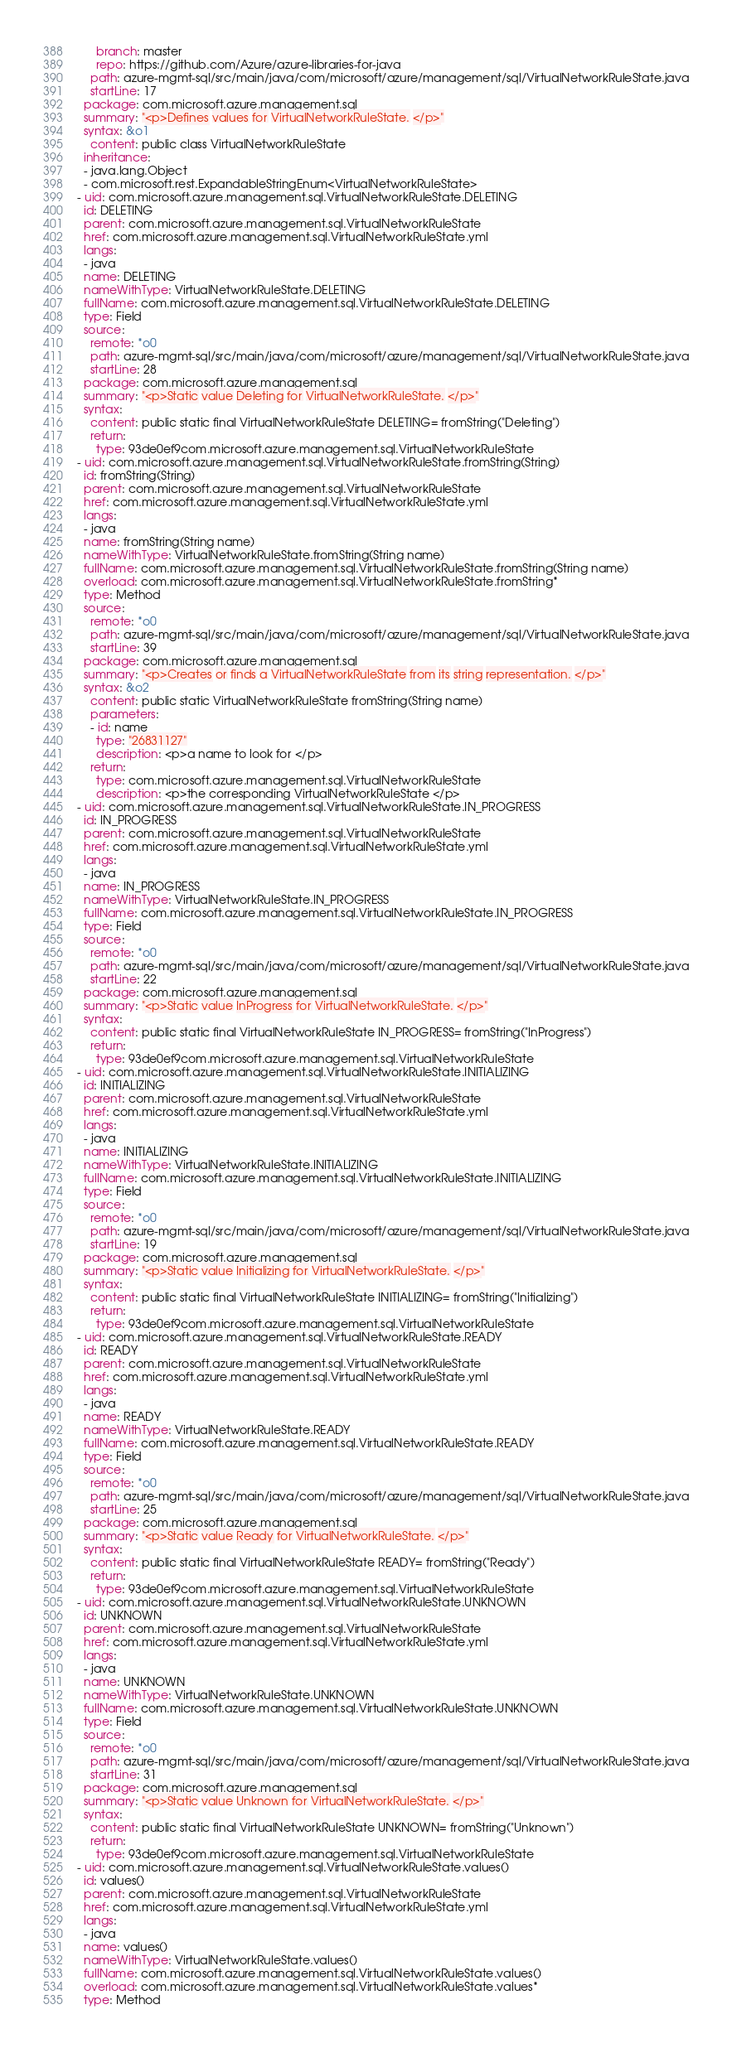Convert code to text. <code><loc_0><loc_0><loc_500><loc_500><_YAML_>      branch: master
      repo: https://github.com/Azure/azure-libraries-for-java
    path: azure-mgmt-sql/src/main/java/com/microsoft/azure/management/sql/VirtualNetworkRuleState.java
    startLine: 17
  package: com.microsoft.azure.management.sql
  summary: "<p>Defines values for VirtualNetworkRuleState. </p>"
  syntax: &o1
    content: public class VirtualNetworkRuleState
  inheritance:
  - java.lang.Object
  - com.microsoft.rest.ExpandableStringEnum<VirtualNetworkRuleState>
- uid: com.microsoft.azure.management.sql.VirtualNetworkRuleState.DELETING
  id: DELETING
  parent: com.microsoft.azure.management.sql.VirtualNetworkRuleState
  href: com.microsoft.azure.management.sql.VirtualNetworkRuleState.yml
  langs:
  - java
  name: DELETING
  nameWithType: VirtualNetworkRuleState.DELETING
  fullName: com.microsoft.azure.management.sql.VirtualNetworkRuleState.DELETING
  type: Field
  source:
    remote: *o0
    path: azure-mgmt-sql/src/main/java/com/microsoft/azure/management/sql/VirtualNetworkRuleState.java
    startLine: 28
  package: com.microsoft.azure.management.sql
  summary: "<p>Static value Deleting for VirtualNetworkRuleState. </p>"
  syntax:
    content: public static final VirtualNetworkRuleState DELETING= fromString("Deleting")
    return:
      type: 93de0ef9com.microsoft.azure.management.sql.VirtualNetworkRuleState
- uid: com.microsoft.azure.management.sql.VirtualNetworkRuleState.fromString(String)
  id: fromString(String)
  parent: com.microsoft.azure.management.sql.VirtualNetworkRuleState
  href: com.microsoft.azure.management.sql.VirtualNetworkRuleState.yml
  langs:
  - java
  name: fromString(String name)
  nameWithType: VirtualNetworkRuleState.fromString(String name)
  fullName: com.microsoft.azure.management.sql.VirtualNetworkRuleState.fromString(String name)
  overload: com.microsoft.azure.management.sql.VirtualNetworkRuleState.fromString*
  type: Method
  source:
    remote: *o0
    path: azure-mgmt-sql/src/main/java/com/microsoft/azure/management/sql/VirtualNetworkRuleState.java
    startLine: 39
  package: com.microsoft.azure.management.sql
  summary: "<p>Creates or finds a VirtualNetworkRuleState from its string representation. </p>"
  syntax: &o2
    content: public static VirtualNetworkRuleState fromString(String name)
    parameters:
    - id: name
      type: "26831127"
      description: <p>a name to look for </p>
    return:
      type: com.microsoft.azure.management.sql.VirtualNetworkRuleState
      description: <p>the corresponding VirtualNetworkRuleState </p>
- uid: com.microsoft.azure.management.sql.VirtualNetworkRuleState.IN_PROGRESS
  id: IN_PROGRESS
  parent: com.microsoft.azure.management.sql.VirtualNetworkRuleState
  href: com.microsoft.azure.management.sql.VirtualNetworkRuleState.yml
  langs:
  - java
  name: IN_PROGRESS
  nameWithType: VirtualNetworkRuleState.IN_PROGRESS
  fullName: com.microsoft.azure.management.sql.VirtualNetworkRuleState.IN_PROGRESS
  type: Field
  source:
    remote: *o0
    path: azure-mgmt-sql/src/main/java/com/microsoft/azure/management/sql/VirtualNetworkRuleState.java
    startLine: 22
  package: com.microsoft.azure.management.sql
  summary: "<p>Static value InProgress for VirtualNetworkRuleState. </p>"
  syntax:
    content: public static final VirtualNetworkRuleState IN_PROGRESS= fromString("InProgress")
    return:
      type: 93de0ef9com.microsoft.azure.management.sql.VirtualNetworkRuleState
- uid: com.microsoft.azure.management.sql.VirtualNetworkRuleState.INITIALIZING
  id: INITIALIZING
  parent: com.microsoft.azure.management.sql.VirtualNetworkRuleState
  href: com.microsoft.azure.management.sql.VirtualNetworkRuleState.yml
  langs:
  - java
  name: INITIALIZING
  nameWithType: VirtualNetworkRuleState.INITIALIZING
  fullName: com.microsoft.azure.management.sql.VirtualNetworkRuleState.INITIALIZING
  type: Field
  source:
    remote: *o0
    path: azure-mgmt-sql/src/main/java/com/microsoft/azure/management/sql/VirtualNetworkRuleState.java
    startLine: 19
  package: com.microsoft.azure.management.sql
  summary: "<p>Static value Initializing for VirtualNetworkRuleState. </p>"
  syntax:
    content: public static final VirtualNetworkRuleState INITIALIZING= fromString("Initializing")
    return:
      type: 93de0ef9com.microsoft.azure.management.sql.VirtualNetworkRuleState
- uid: com.microsoft.azure.management.sql.VirtualNetworkRuleState.READY
  id: READY
  parent: com.microsoft.azure.management.sql.VirtualNetworkRuleState
  href: com.microsoft.azure.management.sql.VirtualNetworkRuleState.yml
  langs:
  - java
  name: READY
  nameWithType: VirtualNetworkRuleState.READY
  fullName: com.microsoft.azure.management.sql.VirtualNetworkRuleState.READY
  type: Field
  source:
    remote: *o0
    path: azure-mgmt-sql/src/main/java/com/microsoft/azure/management/sql/VirtualNetworkRuleState.java
    startLine: 25
  package: com.microsoft.azure.management.sql
  summary: "<p>Static value Ready for VirtualNetworkRuleState. </p>"
  syntax:
    content: public static final VirtualNetworkRuleState READY= fromString("Ready")
    return:
      type: 93de0ef9com.microsoft.azure.management.sql.VirtualNetworkRuleState
- uid: com.microsoft.azure.management.sql.VirtualNetworkRuleState.UNKNOWN
  id: UNKNOWN
  parent: com.microsoft.azure.management.sql.VirtualNetworkRuleState
  href: com.microsoft.azure.management.sql.VirtualNetworkRuleState.yml
  langs:
  - java
  name: UNKNOWN
  nameWithType: VirtualNetworkRuleState.UNKNOWN
  fullName: com.microsoft.azure.management.sql.VirtualNetworkRuleState.UNKNOWN
  type: Field
  source:
    remote: *o0
    path: azure-mgmt-sql/src/main/java/com/microsoft/azure/management/sql/VirtualNetworkRuleState.java
    startLine: 31
  package: com.microsoft.azure.management.sql
  summary: "<p>Static value Unknown for VirtualNetworkRuleState. </p>"
  syntax:
    content: public static final VirtualNetworkRuleState UNKNOWN= fromString("Unknown")
    return:
      type: 93de0ef9com.microsoft.azure.management.sql.VirtualNetworkRuleState
- uid: com.microsoft.azure.management.sql.VirtualNetworkRuleState.values()
  id: values()
  parent: com.microsoft.azure.management.sql.VirtualNetworkRuleState
  href: com.microsoft.azure.management.sql.VirtualNetworkRuleState.yml
  langs:
  - java
  name: values()
  nameWithType: VirtualNetworkRuleState.values()
  fullName: com.microsoft.azure.management.sql.VirtualNetworkRuleState.values()
  overload: com.microsoft.azure.management.sql.VirtualNetworkRuleState.values*
  type: Method</code> 